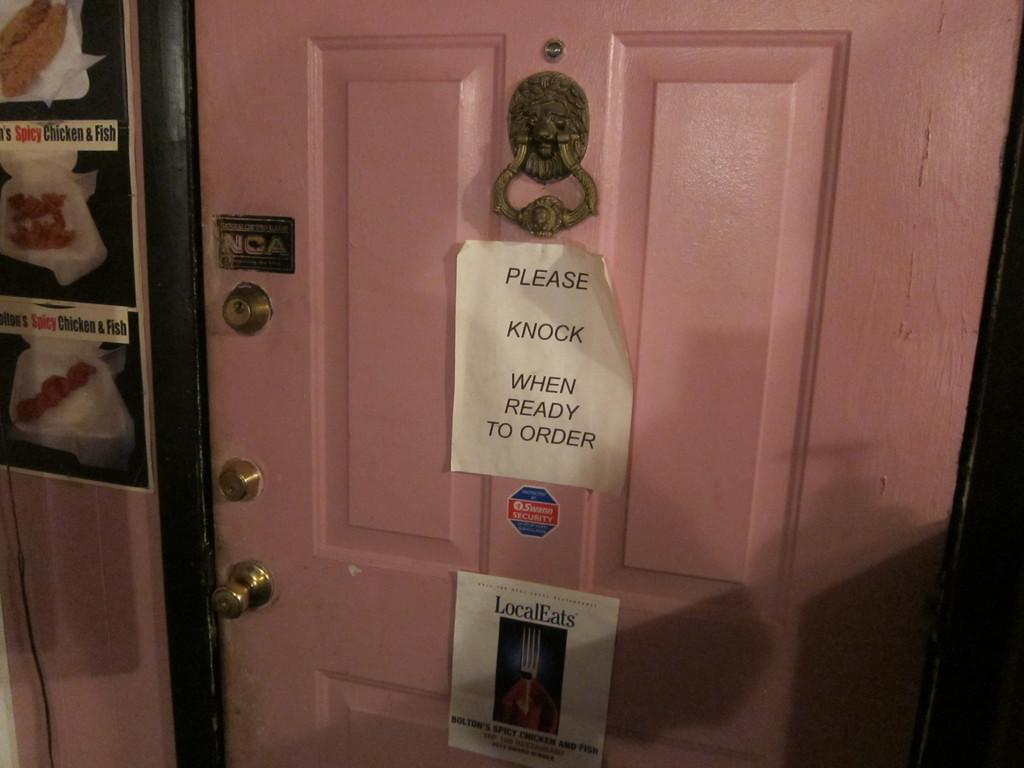<image>
Summarize the visual content of the image. A paper sign on the door instructing people to please knock on the door when they are ready to order. 